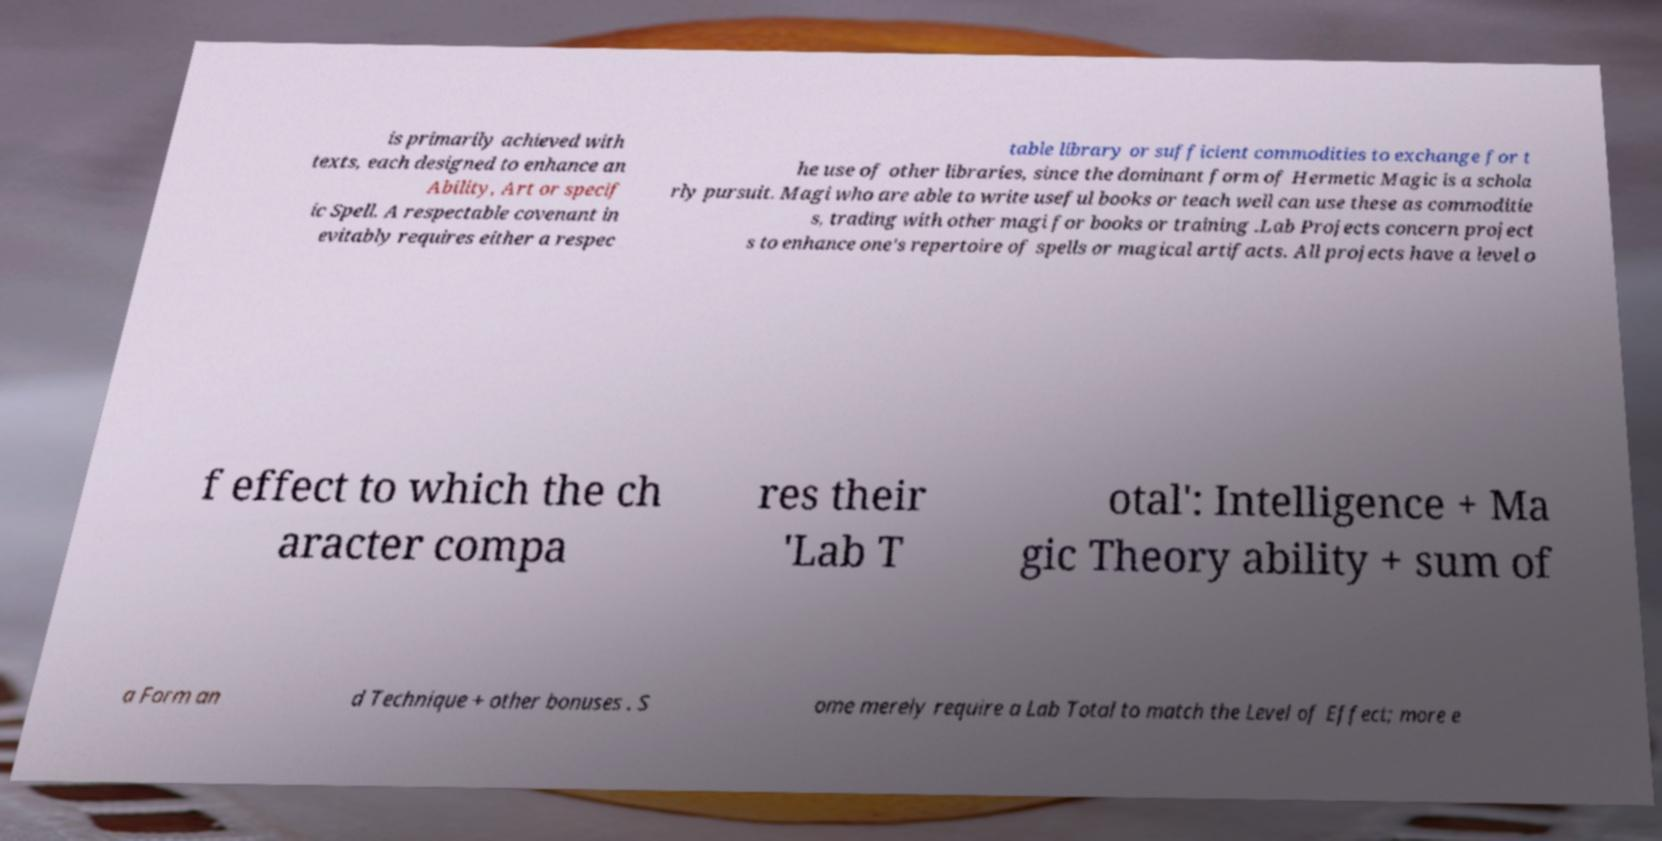Please identify and transcribe the text found in this image. is primarily achieved with texts, each designed to enhance an Ability, Art or specif ic Spell. A respectable covenant in evitably requires either a respec table library or sufficient commodities to exchange for t he use of other libraries, since the dominant form of Hermetic Magic is a schola rly pursuit. Magi who are able to write useful books or teach well can use these as commoditie s, trading with other magi for books or training .Lab Projects concern project s to enhance one's repertoire of spells or magical artifacts. All projects have a level o f effect to which the ch aracter compa res their 'Lab T otal': Intelligence + Ma gic Theory ability + sum of a Form an d Technique + other bonuses . S ome merely require a Lab Total to match the Level of Effect; more e 